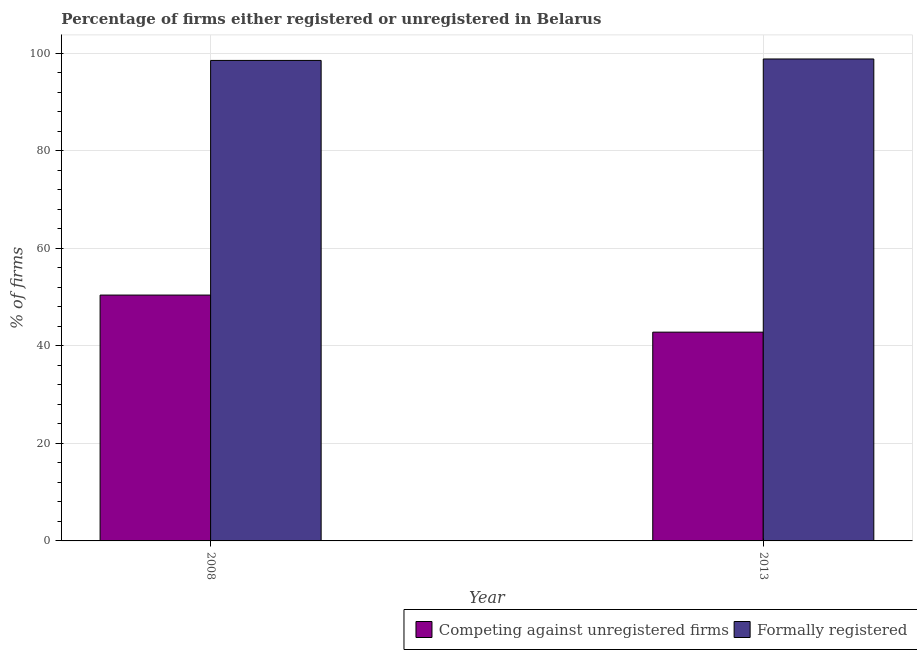How many different coloured bars are there?
Keep it short and to the point. 2. Are the number of bars per tick equal to the number of legend labels?
Ensure brevity in your answer.  Yes. Are the number of bars on each tick of the X-axis equal?
Provide a succinct answer. Yes. In how many cases, is the number of bars for a given year not equal to the number of legend labels?
Your answer should be very brief. 0. What is the percentage of registered firms in 2008?
Give a very brief answer. 50.4. Across all years, what is the maximum percentage of registered firms?
Your answer should be compact. 50.4. Across all years, what is the minimum percentage of registered firms?
Offer a terse response. 42.8. In which year was the percentage of formally registered firms maximum?
Your answer should be compact. 2013. What is the total percentage of registered firms in the graph?
Make the answer very short. 93.2. What is the difference between the percentage of formally registered firms in 2008 and that in 2013?
Your response must be concise. -0.3. What is the difference between the percentage of registered firms in 2008 and the percentage of formally registered firms in 2013?
Offer a terse response. 7.6. What is the average percentage of registered firms per year?
Ensure brevity in your answer.  46.6. In how many years, is the percentage of registered firms greater than 48 %?
Provide a succinct answer. 1. What is the ratio of the percentage of registered firms in 2008 to that in 2013?
Your answer should be compact. 1.18. Is the percentage of registered firms in 2008 less than that in 2013?
Keep it short and to the point. No. In how many years, is the percentage of registered firms greater than the average percentage of registered firms taken over all years?
Keep it short and to the point. 1. What does the 1st bar from the left in 2013 represents?
Provide a succinct answer. Competing against unregistered firms. What does the 2nd bar from the right in 2008 represents?
Your response must be concise. Competing against unregistered firms. How many years are there in the graph?
Ensure brevity in your answer.  2. What is the difference between two consecutive major ticks on the Y-axis?
Offer a very short reply. 20. Are the values on the major ticks of Y-axis written in scientific E-notation?
Keep it short and to the point. No. Does the graph contain any zero values?
Your answer should be very brief. No. What is the title of the graph?
Ensure brevity in your answer.  Percentage of firms either registered or unregistered in Belarus. What is the label or title of the X-axis?
Offer a terse response. Year. What is the label or title of the Y-axis?
Make the answer very short. % of firms. What is the % of firms of Competing against unregistered firms in 2008?
Provide a succinct answer. 50.4. What is the % of firms of Formally registered in 2008?
Your answer should be very brief. 98.5. What is the % of firms of Competing against unregistered firms in 2013?
Provide a short and direct response. 42.8. What is the % of firms of Formally registered in 2013?
Provide a succinct answer. 98.8. Across all years, what is the maximum % of firms of Competing against unregistered firms?
Offer a very short reply. 50.4. Across all years, what is the maximum % of firms in Formally registered?
Give a very brief answer. 98.8. Across all years, what is the minimum % of firms of Competing against unregistered firms?
Your response must be concise. 42.8. Across all years, what is the minimum % of firms in Formally registered?
Offer a terse response. 98.5. What is the total % of firms of Competing against unregistered firms in the graph?
Make the answer very short. 93.2. What is the total % of firms of Formally registered in the graph?
Offer a terse response. 197.3. What is the difference between the % of firms of Competing against unregistered firms in 2008 and that in 2013?
Make the answer very short. 7.6. What is the difference between the % of firms of Formally registered in 2008 and that in 2013?
Ensure brevity in your answer.  -0.3. What is the difference between the % of firms of Competing against unregistered firms in 2008 and the % of firms of Formally registered in 2013?
Ensure brevity in your answer.  -48.4. What is the average % of firms of Competing against unregistered firms per year?
Make the answer very short. 46.6. What is the average % of firms of Formally registered per year?
Your answer should be very brief. 98.65. In the year 2008, what is the difference between the % of firms in Competing against unregistered firms and % of firms in Formally registered?
Give a very brief answer. -48.1. In the year 2013, what is the difference between the % of firms in Competing against unregistered firms and % of firms in Formally registered?
Your answer should be compact. -56. What is the ratio of the % of firms in Competing against unregistered firms in 2008 to that in 2013?
Your answer should be very brief. 1.18. What is the ratio of the % of firms of Formally registered in 2008 to that in 2013?
Provide a succinct answer. 1. What is the difference between the highest and the second highest % of firms of Competing against unregistered firms?
Your answer should be very brief. 7.6. What is the difference between the highest and the second highest % of firms in Formally registered?
Provide a succinct answer. 0.3. What is the difference between the highest and the lowest % of firms of Competing against unregistered firms?
Offer a terse response. 7.6. What is the difference between the highest and the lowest % of firms in Formally registered?
Your answer should be compact. 0.3. 